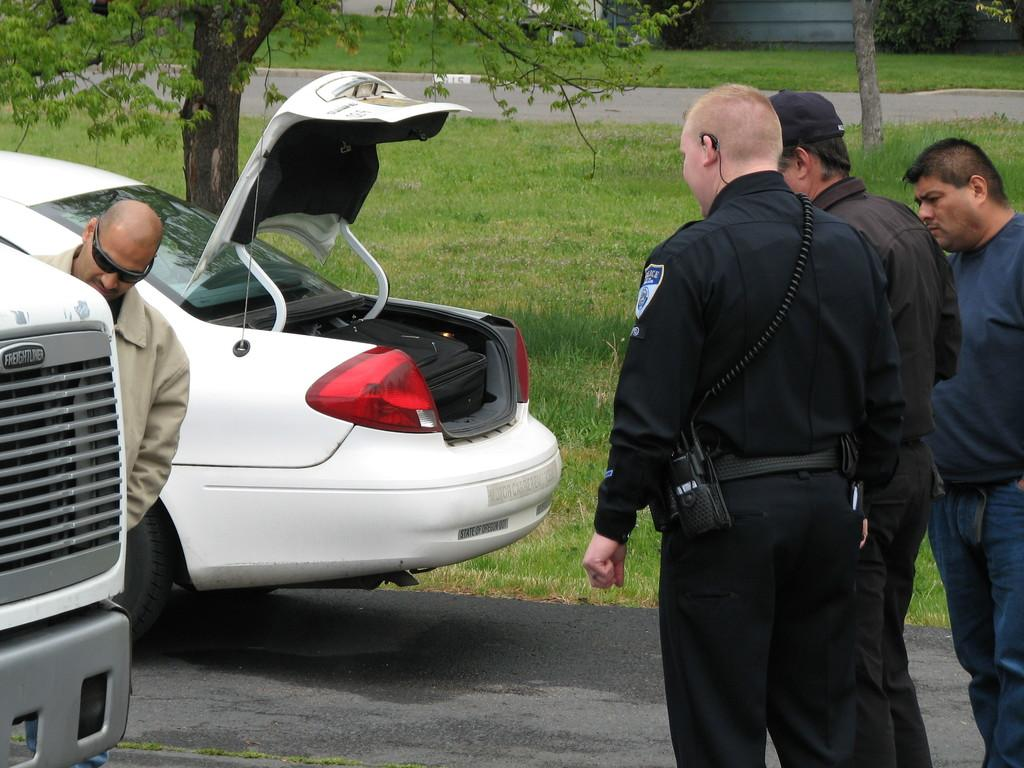What is happening on the road in the image? There are cars on a road in the image. How many men are standing in the image? There are four men standing in the image. What can be seen in the background of the image? Greenland and trees are visible in the background of the image. What type of cap is the man in the image wearing? There is no man wearing a cap in the image. Is there any smoke visible in the image? There is no smoke present in the image. 